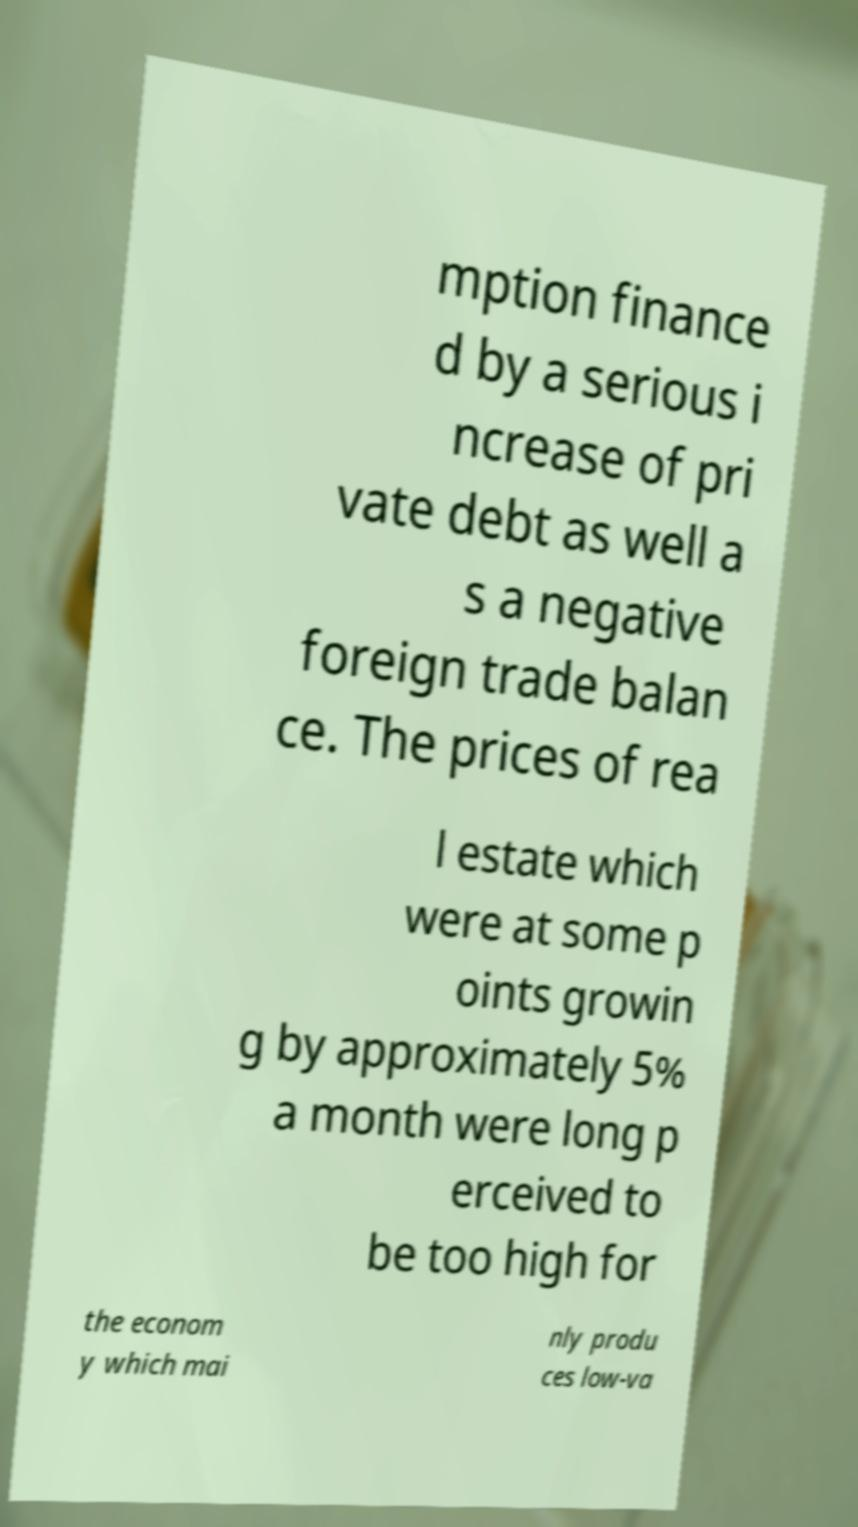Please read and relay the text visible in this image. What does it say? mption finance d by a serious i ncrease of pri vate debt as well a s a negative foreign trade balan ce. The prices of rea l estate which were at some p oints growin g by approximately 5% a month were long p erceived to be too high for the econom y which mai nly produ ces low-va 